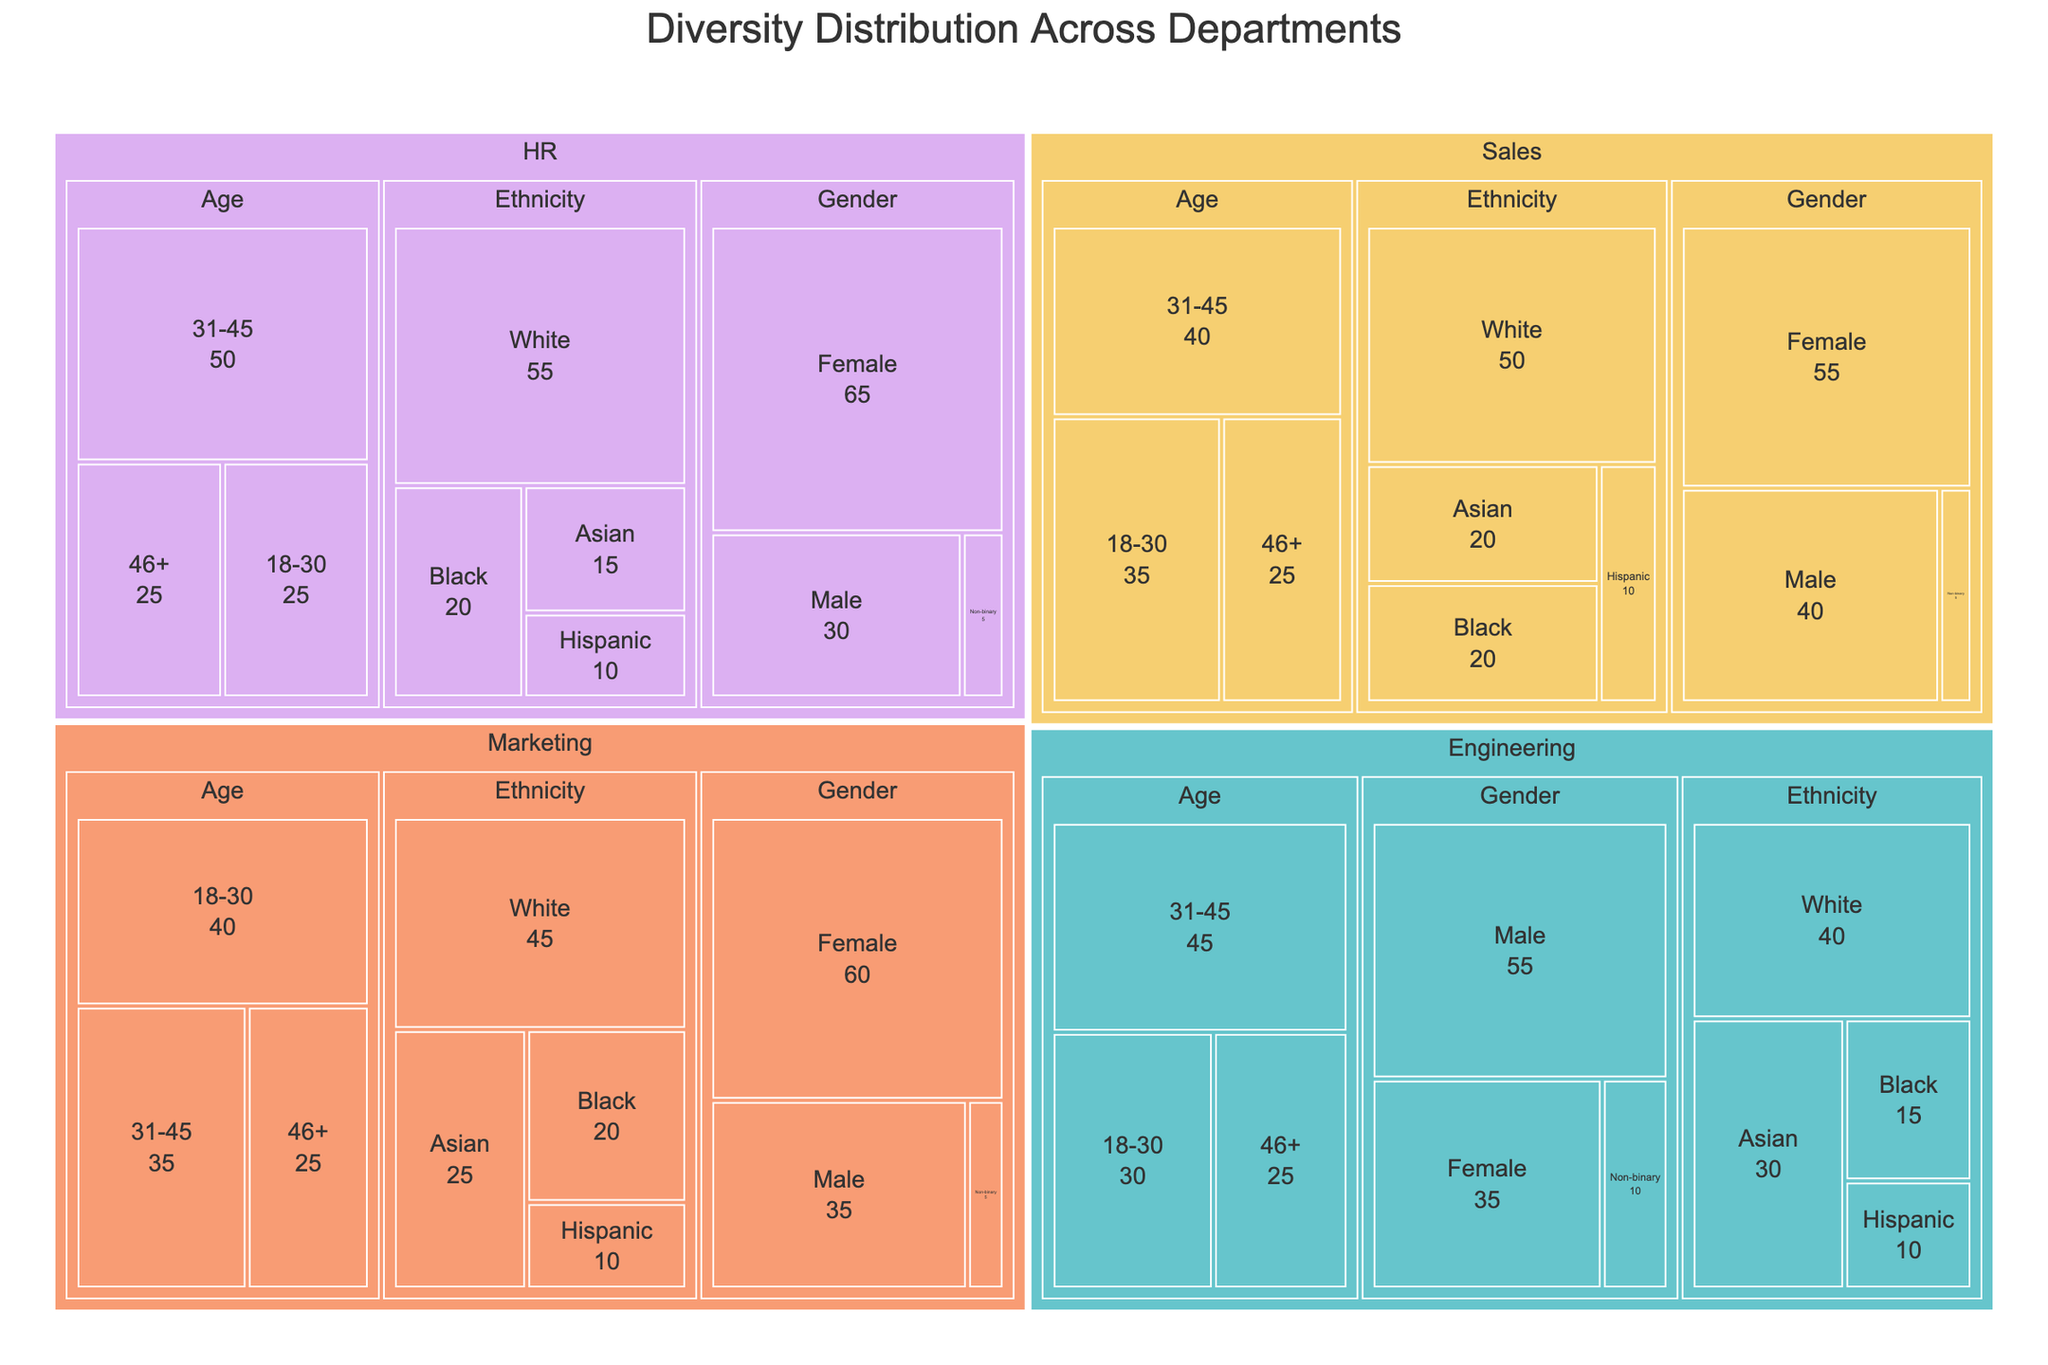what is the title of the treemap? The title of the treemap is usually located at the top of the figure. From the given code, the title is set as 'Diversity Distribution Across Departments'.
Answer: Diversity Distribution Across Departments What is the color scheme used for different departments? The color scheme used for different departments is outlined in the 'color_discrete_sequence'. Colors would be 'Pastel' shades unique for each department.
Answer: Pastel shades What is the value for Non-binary employees in the Sales department? Locate the Sales department, then look for the 'Gender' category and subsequently the 'Non-binary' subcategory. The value provided in the data for Sales Non-binary employees is 5.
Answer: 5 Which department has the highest number of Male employees? Compare the values of Male employees across departments: Engineering (55), Sales (40), Marketing (35), HR (30). The highest value is 55 in Engineering.
Answer: Engineering What is the total number of employees in the Marketing department? Sum all the values across all categories and subcategories in the Marketing department: 35 (Male) + 60 (Female) + 5 (Non-binary) + 45 (White) + 25 (Asian) + 20 (Black) + 10 (Hispanic) + 40 (18-30) + 35 (31-45) + 25 (46+). The result is 300.
Answer: 300 How many more Female employees are there than Male employees in the HR department? Subtract the number of Male employees in HR (30) from the number of Female employees in HR (65). The result is 65 - 30 = 35.
Answer: 35 Which age group is the least represented in the Engineering department? Compare the values of different age groups in the Engineering department: 18-30 (30), 31-45 (45), 46+ (25). The least represented is '46+'.
Answer: 46+ What is the difference in the number of Asian employees between Marketing and Sales departments? Subtract the number of Asian employees in Sales (20) from the number in Marketing (25). Calculation: 25 - 20 = 5.
Answer: 5 What is the combined number of employees from the Black ethnicity across all departments? Sum the values for Black ethnicity across all departments: Engineering (15) + Sales (20) + Marketing (20) + HR (20). The result is 15 + 20 + 20 + 20 = 75.
Answer: 75 Which department shows a significant gender imbalance and what is the ratio of Male to Female employees in that department? The HR department shows significant gender imbalance with 30 Male and 65 Female employees. The ratio is calculated as 30/65, which simplifies to approximately 0.46:1.
Answer: HR, 0.46:1 